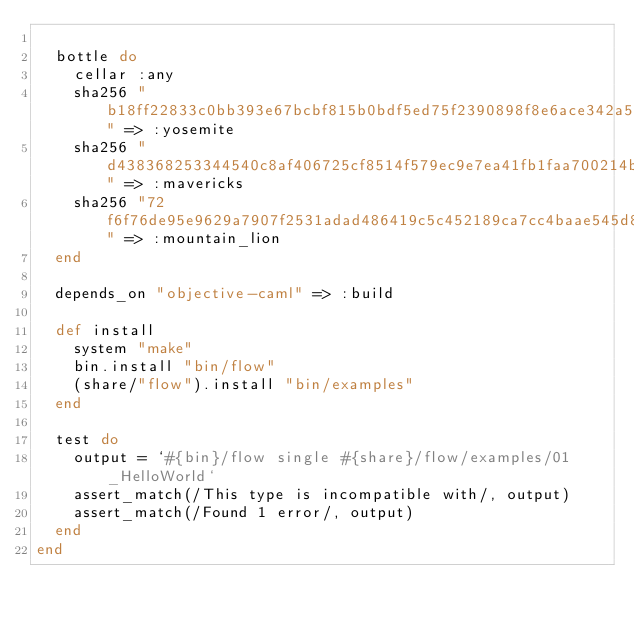<code> <loc_0><loc_0><loc_500><loc_500><_Ruby_>
  bottle do
    cellar :any
    sha256 "b18ff22833c0bb393e67bcbf815b0bdf5ed75f2390898f8e6ace342a5d8f79f9" => :yosemite
    sha256 "d438368253344540c8af406725cf8514f579ec9e7ea41fb1faa700214b131d44" => :mavericks
    sha256 "72f6f76de95e9629a7907f2531adad486419c5c452189ca7cc4baae545d82174" => :mountain_lion
  end

  depends_on "objective-caml" => :build

  def install
    system "make"
    bin.install "bin/flow"
    (share/"flow").install "bin/examples"
  end

  test do
    output = `#{bin}/flow single #{share}/flow/examples/01_HelloWorld`
    assert_match(/This type is incompatible with/, output)
    assert_match(/Found 1 error/, output)
  end
end
</code> 